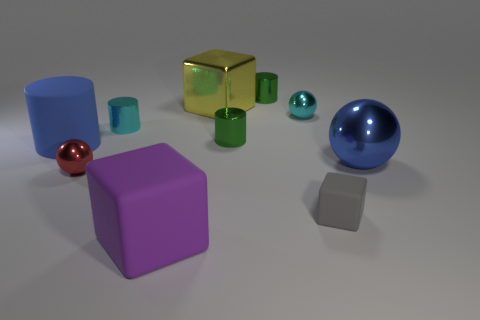Does the large shiny cube have the same color as the ball on the left side of the large yellow shiny cube? no 